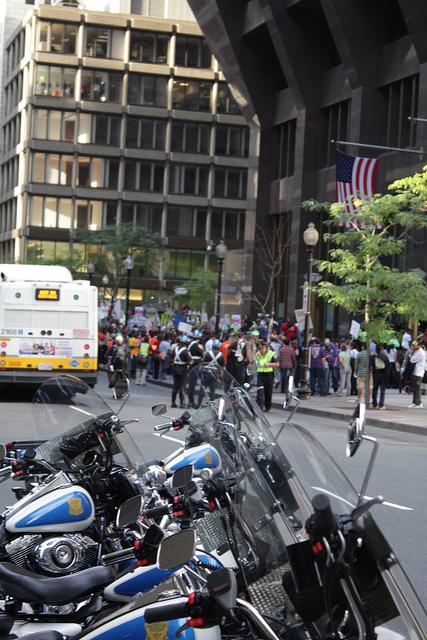How many lanes are on this highway?
Be succinct. 2. How many people are shown?
Write a very short answer. Many. What kind of rally might be going on?
Give a very brief answer. Motorcycle. How many motorcyclists are there?
Answer briefly. 2. Is there a bus in the picture?
Write a very short answer. Yes. Is there at least one motorcycle in this picture?
Keep it brief. Yes. How many motorcycles are there?
Be succinct. 3. How many people are in the street?
Give a very brief answer. 30. Is that a palm tree?
Give a very brief answer. No. 